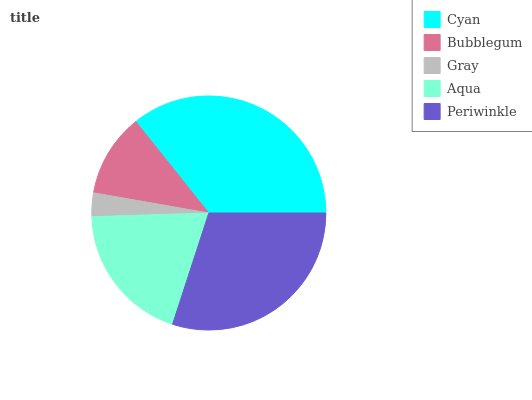Is Gray the minimum?
Answer yes or no. Yes. Is Cyan the maximum?
Answer yes or no. Yes. Is Bubblegum the minimum?
Answer yes or no. No. Is Bubblegum the maximum?
Answer yes or no. No. Is Cyan greater than Bubblegum?
Answer yes or no. Yes. Is Bubblegum less than Cyan?
Answer yes or no. Yes. Is Bubblegum greater than Cyan?
Answer yes or no. No. Is Cyan less than Bubblegum?
Answer yes or no. No. Is Aqua the high median?
Answer yes or no. Yes. Is Aqua the low median?
Answer yes or no. Yes. Is Periwinkle the high median?
Answer yes or no. No. Is Periwinkle the low median?
Answer yes or no. No. 